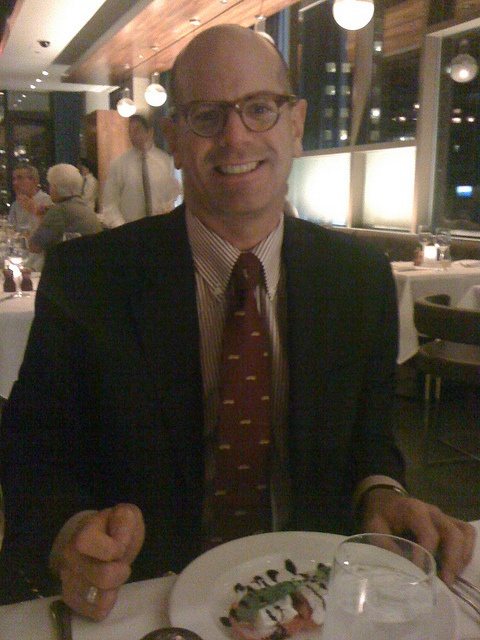Describe the objects in this image and their specific colors. I can see people in black, maroon, and gray tones, cup in black and gray tones, wine glass in black and gray tones, tie in black, maroon, and gray tones, and people in black, gray, and darkgray tones in this image. 